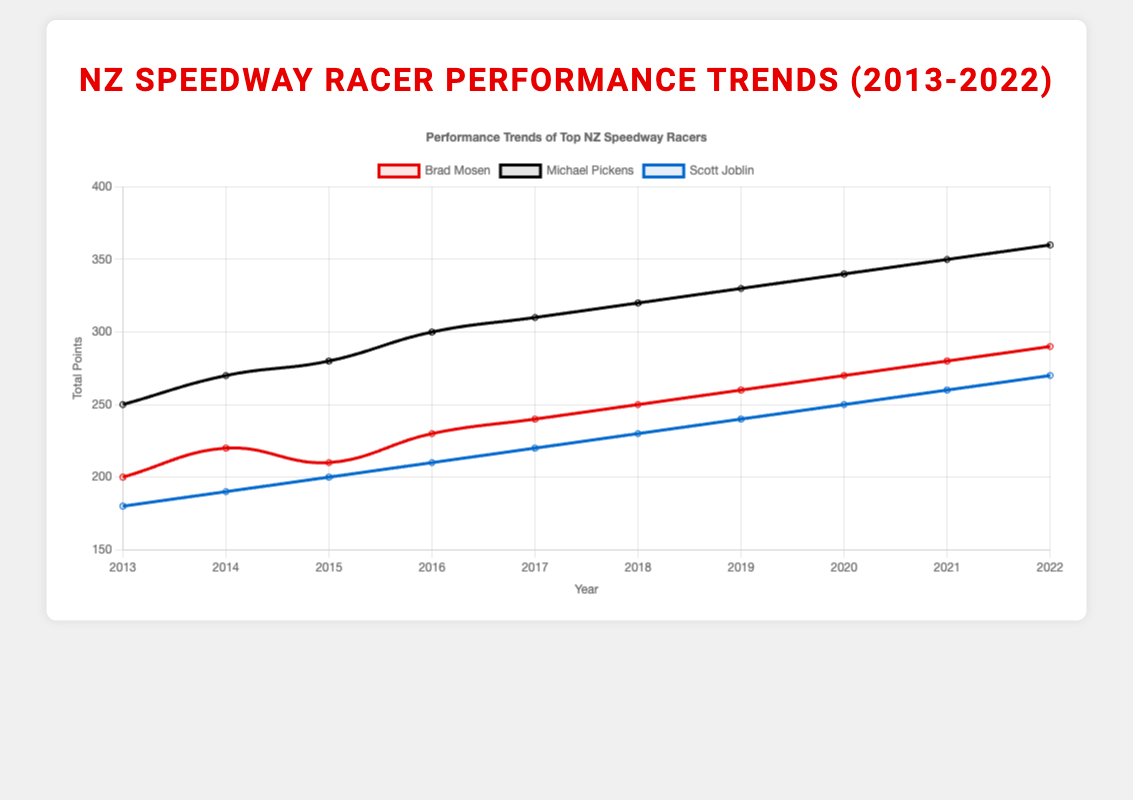What is the total increase in points for Michael Pickens from 2013 to 2022? To find the total increase, subtract the total points in 2013 (250) from the total points in 2022 (360). Therefore, 360 - 250 = 110.
Answer: 110 Which racer had the highest total points in 2020? Check the total points for each racer in 2020: Brad Mosen (270), Michael Pickens (340), and Scott Joblin (250). Michael Pickens has the highest total points.
Answer: Michael Pickens How many years did Brad Mosen score less than 240 points? Identify the total points for Brad Mosen each year and count the occurrences where the points are less than 240 (2013: 200, 2014: 220, 2015: 210, 2016: 230). There are 4 years.
Answer: 4 years By how much did Scott Joblin's total points increase from 2013 to 2022? Subtract Scott Joblin's total points in 2013 (180) from his total points in 2022 (270). Therefore, 270 - 180 = 90.
Answer: 90 In which year did all three racers reach or surpass a total of 200 points? Verify the total points for each racer in every year to find the year when each of them had at least 200 points. In 2015, Brad Mosen had 210 points, Michael Pickens had 280 points, and Scott Joblin had 200 points.
Answer: 2015 Which racer shows a consistent increase in total points every year? Examine the year-by-year points for each racer. Michael Pickens shows a consistent increase from 2013 to 2022 without any drop.
Answer: Michael Pickens What is the average total points for Scott Joblin across the decade? Add Scott Joblin's total points for each year (180 + 190 + 200 + 210 + 220 + 230 + 240 + 250 + 260 + 270 = 2250) and divide by 10. Therefore, 2250 / 10 = 225.
Answer: 225 Compare the points for Brad Mosen and Michael Pickens in 2016. Who scored higher and by how much? Brad Mosen scored 230 points and Michael Pickens scored 300 points in 2016. The difference is 300 - 230 = 70. Michael Pickens scored higher by 70 points.
Answer: Michael Pickens by 70 What was the trend of total points for Scott Joblin from 2017 to 2022? Analyze the total points for Scott Joblin each year from 2017 (220), 2018 (230), 2019 (240), 2020 (250), 2021 (260), and 2022 (270). The trend shows a consistent increase each year.
Answer: Consistent increase Determine the overall rank of the racers based on their points in 2019. Compare the total points of the racers in 2019: Michael Pickens (330), Brad Mosen (260), and Scott Joblin (240). The rank from highest to lowest is Michael Pickens, Brad Mosen, Scott Joblin.
Answer: Michael Pickens, Brad Mosen, Scott Joblin 